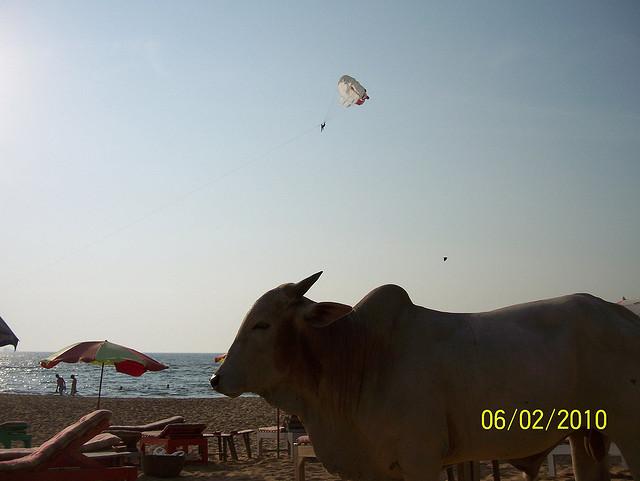Is there a cow on the beach?
Answer briefly. Yes. What year is it?
Keep it brief. 2010. How many people are close to the ocean?
Short answer required. 2. 